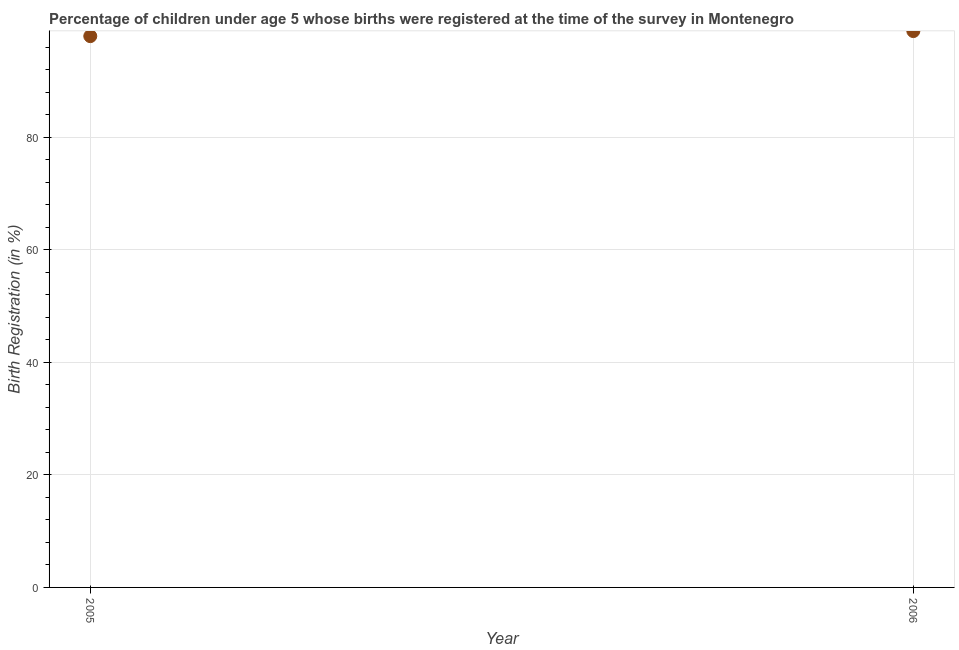Across all years, what is the maximum birth registration?
Make the answer very short. 98.9. In which year was the birth registration maximum?
Keep it short and to the point. 2006. In which year was the birth registration minimum?
Give a very brief answer. 2005. What is the sum of the birth registration?
Keep it short and to the point. 196.9. What is the difference between the birth registration in 2005 and 2006?
Your response must be concise. -0.9. What is the average birth registration per year?
Provide a succinct answer. 98.45. What is the median birth registration?
Offer a terse response. 98.45. Do a majority of the years between 2005 and 2006 (inclusive) have birth registration greater than 48 %?
Offer a terse response. Yes. What is the ratio of the birth registration in 2005 to that in 2006?
Provide a succinct answer. 0.99. In how many years, is the birth registration greater than the average birth registration taken over all years?
Your answer should be compact. 1. How many dotlines are there?
Provide a succinct answer. 1. How many years are there in the graph?
Your response must be concise. 2. Does the graph contain grids?
Provide a succinct answer. Yes. What is the title of the graph?
Make the answer very short. Percentage of children under age 5 whose births were registered at the time of the survey in Montenegro. What is the label or title of the X-axis?
Ensure brevity in your answer.  Year. What is the label or title of the Y-axis?
Your response must be concise. Birth Registration (in %). What is the Birth Registration (in %) in 2005?
Your answer should be compact. 98. What is the Birth Registration (in %) in 2006?
Your answer should be very brief. 98.9. 